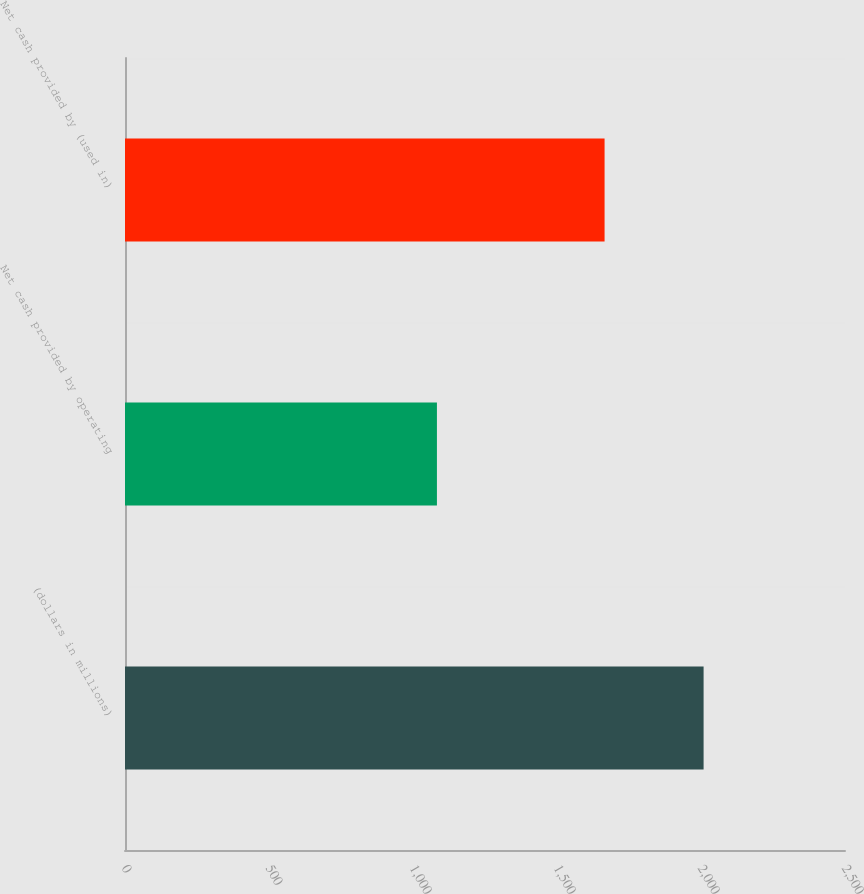Convert chart to OTSL. <chart><loc_0><loc_0><loc_500><loc_500><bar_chart><fcel>(dollars in millions)<fcel>Net cash provided by operating<fcel>Net cash provided by (used in)<nl><fcel>2009<fcel>1083.1<fcel>1665.2<nl></chart> 